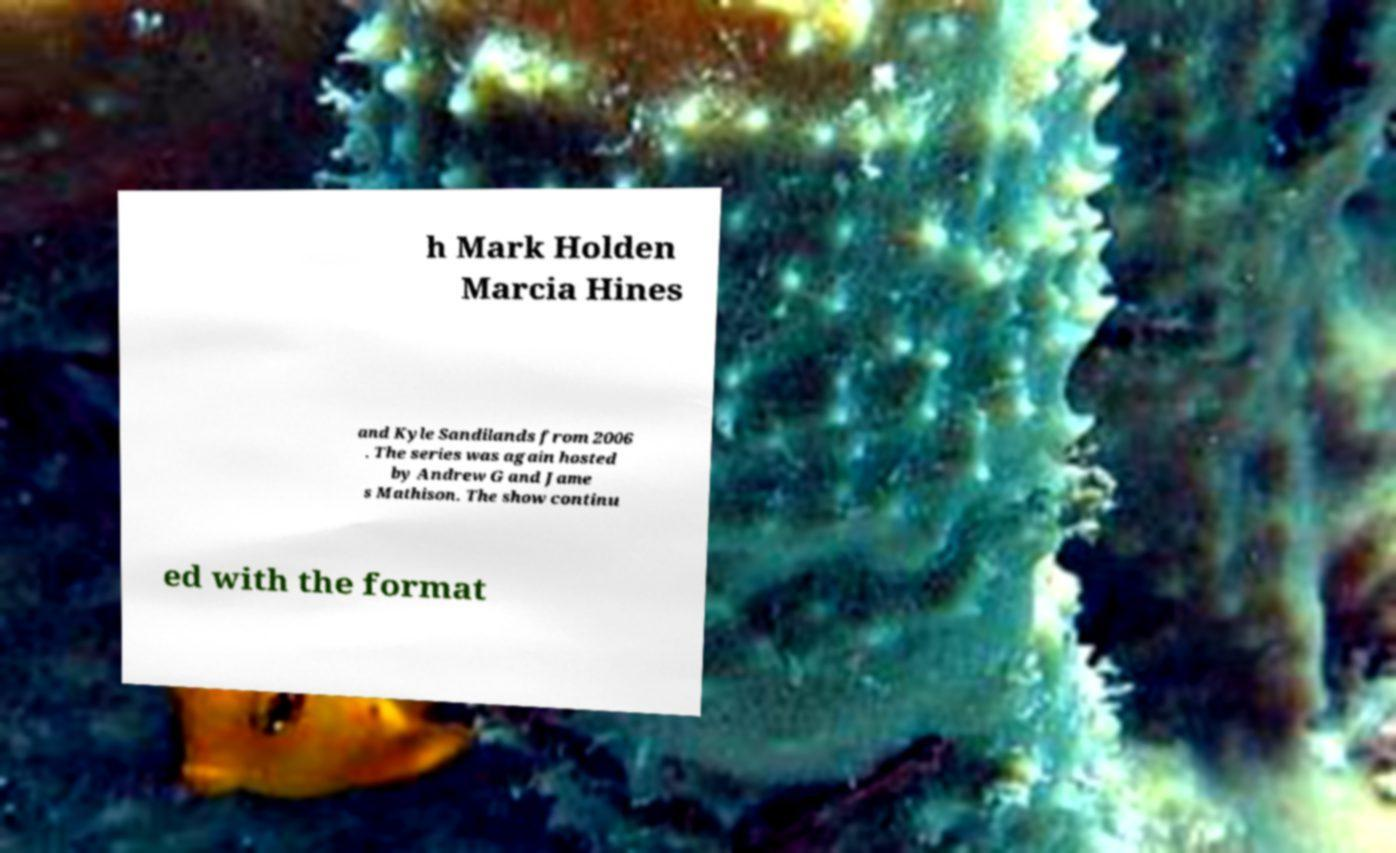Could you assist in decoding the text presented in this image and type it out clearly? h Mark Holden Marcia Hines and Kyle Sandilands from 2006 . The series was again hosted by Andrew G and Jame s Mathison. The show continu ed with the format 